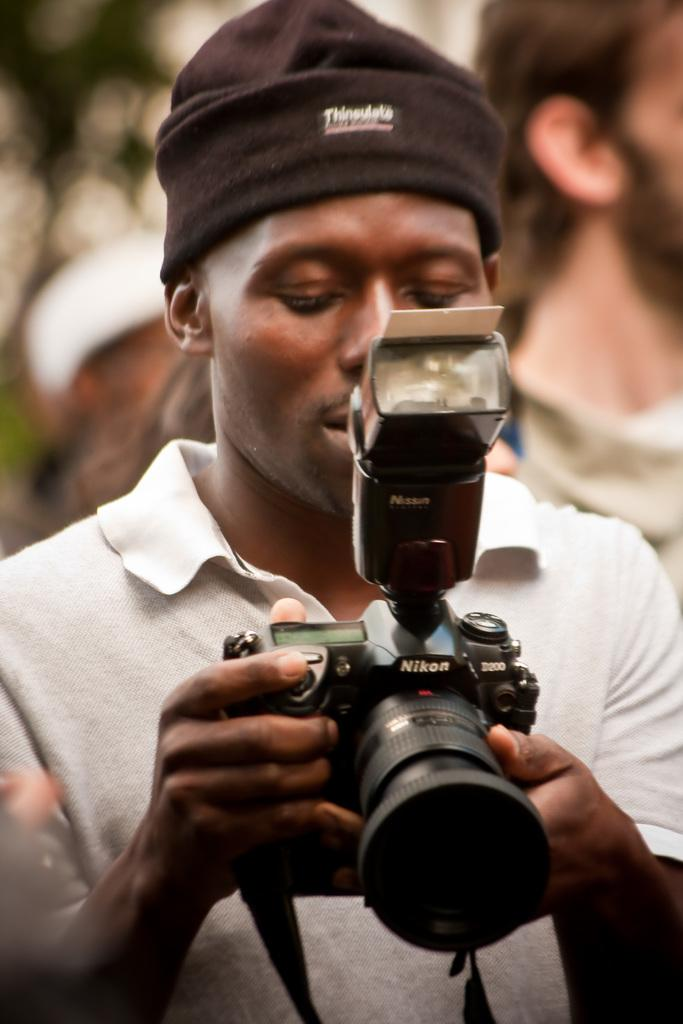<image>
Provide a brief description of the given image. A young man holding a Nikon digital camera. 